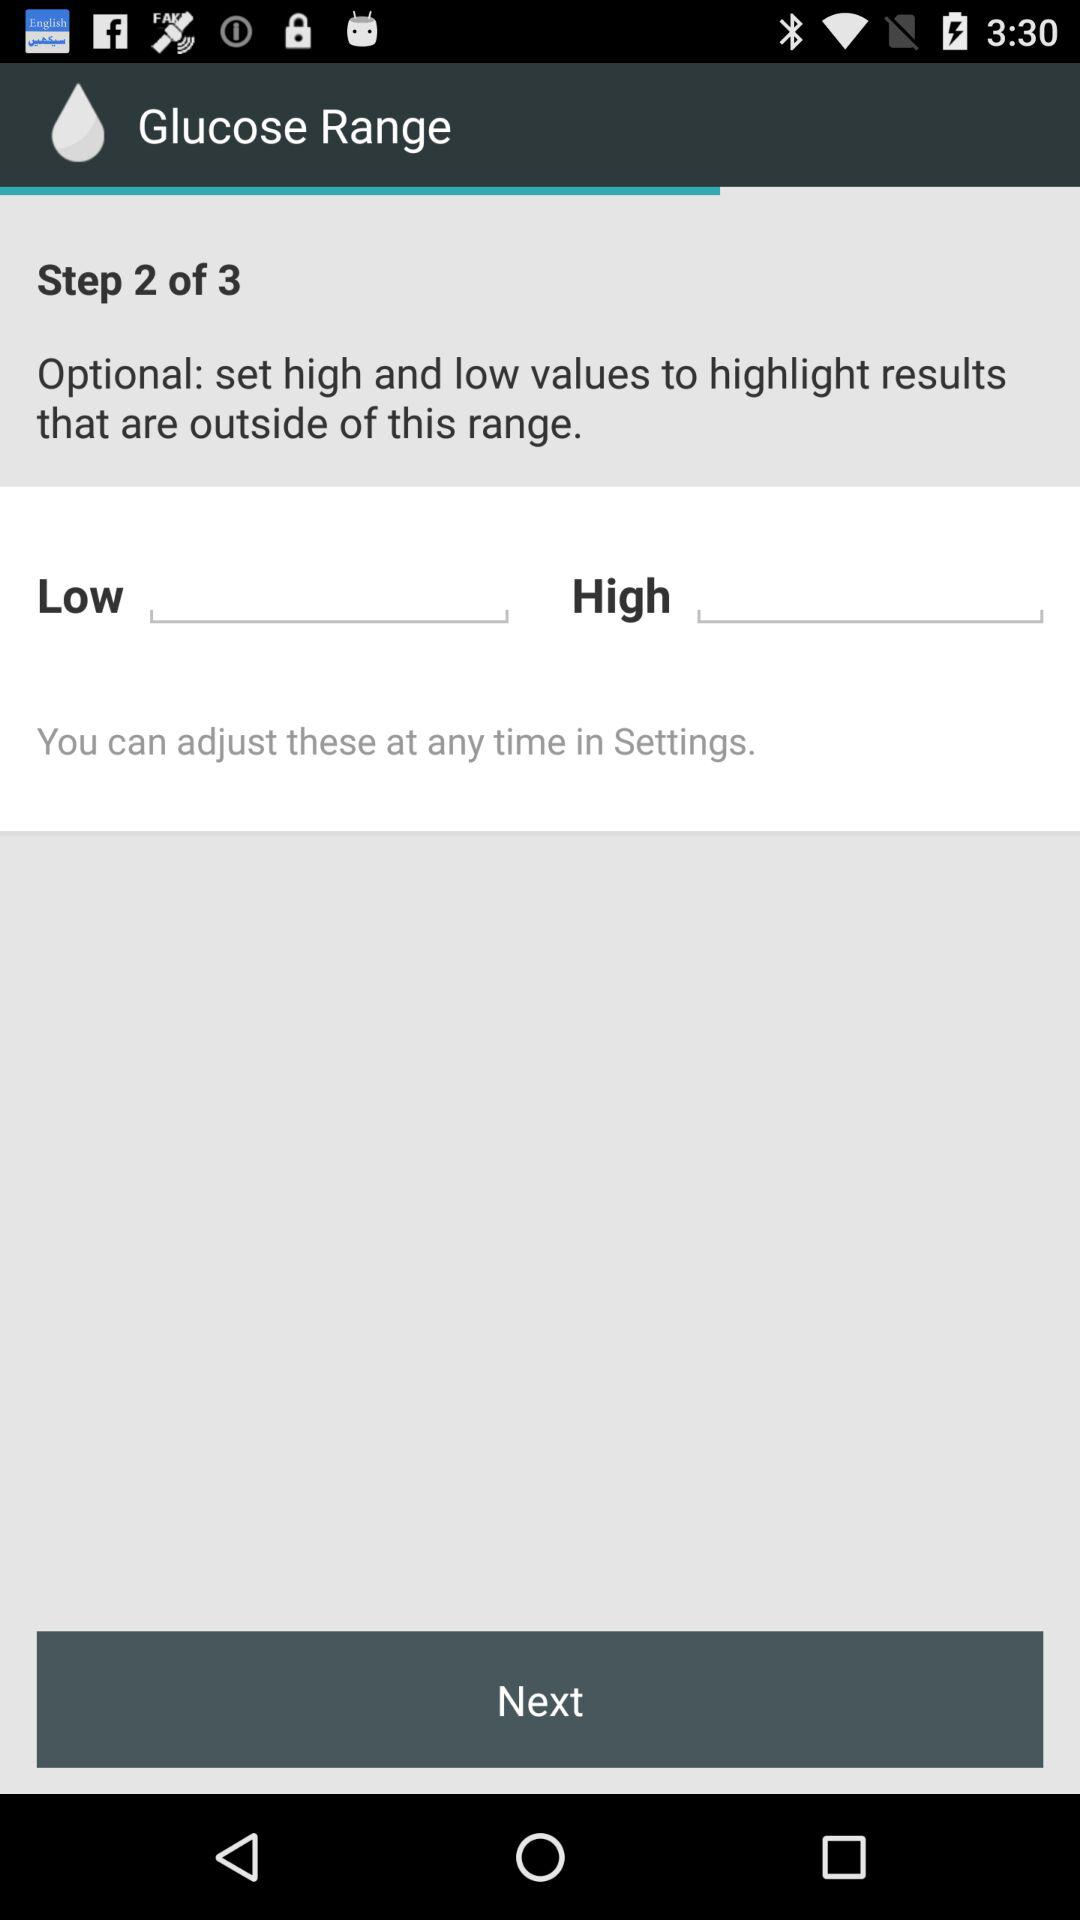How many steps in total are there? There are 3 steps in total. 